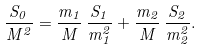Convert formula to latex. <formula><loc_0><loc_0><loc_500><loc_500>\frac { S _ { 0 } } { M ^ { 2 } } = \frac { m _ { 1 } } { M } \, \frac { S _ { 1 } } { m _ { 1 } ^ { 2 } } + \frac { m _ { 2 } } { M } \, \frac { S _ { 2 } } { m _ { 2 } ^ { 2 } } .</formula> 